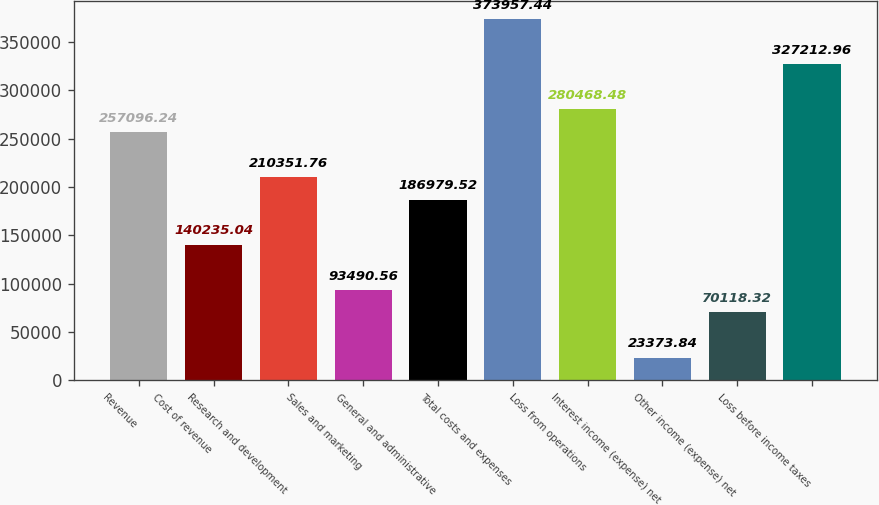<chart> <loc_0><loc_0><loc_500><loc_500><bar_chart><fcel>Revenue<fcel>Cost of revenue<fcel>Research and development<fcel>Sales and marketing<fcel>General and administrative<fcel>Total costs and expenses<fcel>Loss from operations<fcel>Interest income (expense) net<fcel>Other income (expense) net<fcel>Loss before income taxes<nl><fcel>257096<fcel>140235<fcel>210352<fcel>93490.6<fcel>186980<fcel>373957<fcel>280468<fcel>23373.8<fcel>70118.3<fcel>327213<nl></chart> 